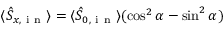<formula> <loc_0><loc_0><loc_500><loc_500>\langle \hat { S } _ { x , i n } \rangle = \langle \hat { S } _ { 0 , i n } \rangle ( \cos ^ { 2 } \alpha - \sin ^ { 2 } \alpha )</formula> 